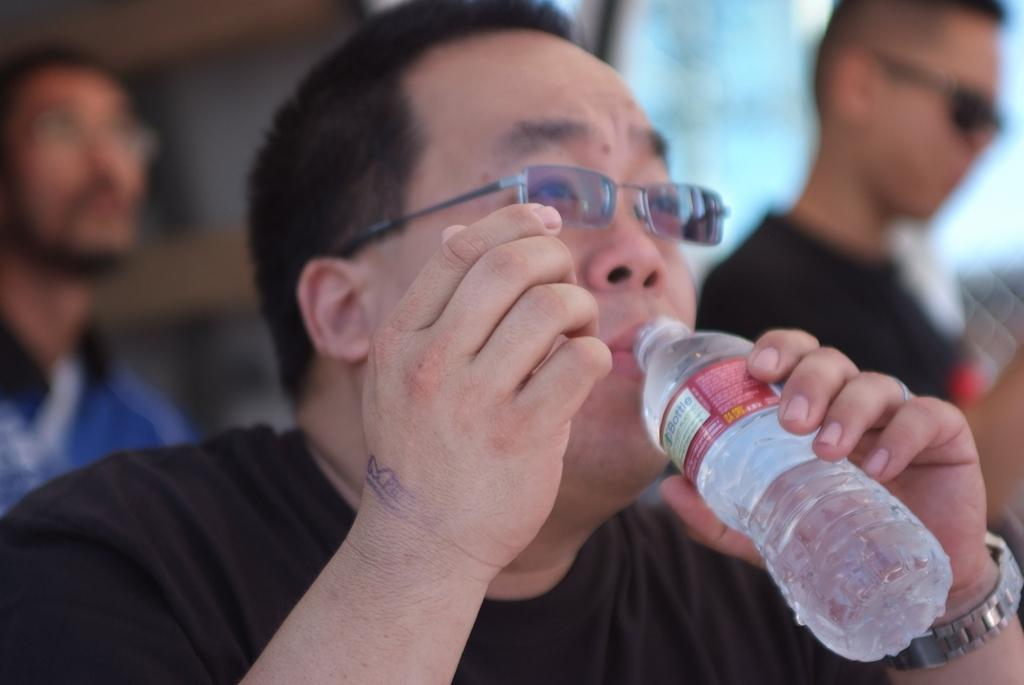What is the person in the image wearing on their upper body? The person is wearing a black t-shirt. What accessory is the person wearing on their face? The person is wearing glasses (specs). What is the person doing in the image? The person is drinking water from a bottle. What time-keeping device is the person wearing? The person is wearing a watch. How many other people are visible in the image? There are two other persons in the background of the image. What type of pen is the person using to smash the clock in the image? There is no pen or clock present in the image, and the person is not smashing anything. 